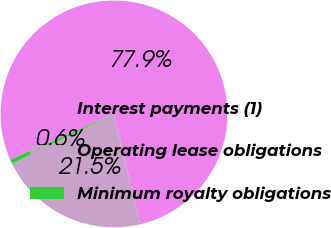Convert chart. <chart><loc_0><loc_0><loc_500><loc_500><pie_chart><fcel>Interest payments (1)<fcel>Operating lease obligations<fcel>Minimum royalty obligations<nl><fcel>77.88%<fcel>21.5%<fcel>0.62%<nl></chart> 